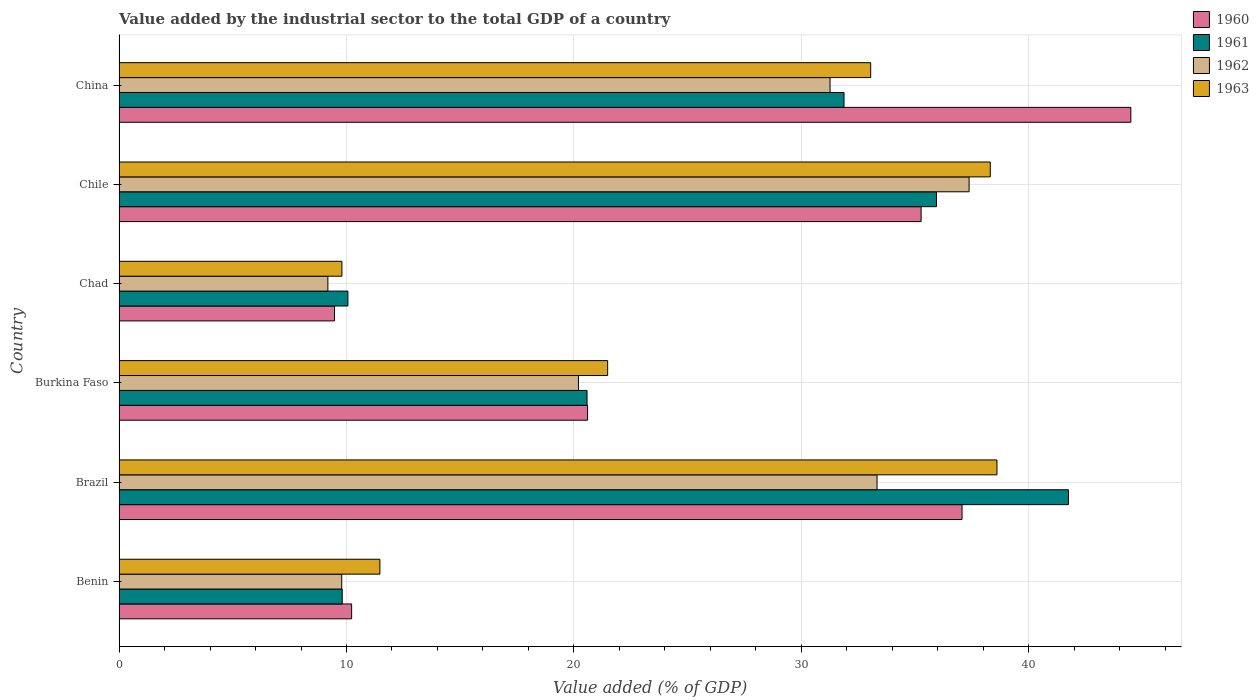How many different coloured bars are there?
Keep it short and to the point. 4. Are the number of bars per tick equal to the number of legend labels?
Keep it short and to the point. Yes. How many bars are there on the 5th tick from the top?
Give a very brief answer. 4. How many bars are there on the 5th tick from the bottom?
Offer a terse response. 4. What is the label of the 6th group of bars from the top?
Give a very brief answer. Benin. In how many cases, is the number of bars for a given country not equal to the number of legend labels?
Your answer should be compact. 0. What is the value added by the industrial sector to the total GDP in 1963 in Chad?
Make the answer very short. 9.8. Across all countries, what is the maximum value added by the industrial sector to the total GDP in 1961?
Provide a short and direct response. 41.75. Across all countries, what is the minimum value added by the industrial sector to the total GDP in 1963?
Offer a very short reply. 9.8. In which country was the value added by the industrial sector to the total GDP in 1960 maximum?
Offer a terse response. China. In which country was the value added by the industrial sector to the total GDP in 1962 minimum?
Provide a short and direct response. Chad. What is the total value added by the industrial sector to the total GDP in 1960 in the graph?
Keep it short and to the point. 157.12. What is the difference between the value added by the industrial sector to the total GDP in 1960 in Brazil and that in Chile?
Keep it short and to the point. 1.8. What is the difference between the value added by the industrial sector to the total GDP in 1963 in Benin and the value added by the industrial sector to the total GDP in 1960 in China?
Your answer should be very brief. -33.02. What is the average value added by the industrial sector to the total GDP in 1962 per country?
Ensure brevity in your answer.  23.52. What is the difference between the value added by the industrial sector to the total GDP in 1960 and value added by the industrial sector to the total GDP in 1963 in Benin?
Your answer should be compact. -1.24. What is the ratio of the value added by the industrial sector to the total GDP in 1962 in Benin to that in Chile?
Offer a terse response. 0.26. What is the difference between the highest and the second highest value added by the industrial sector to the total GDP in 1963?
Your response must be concise. 0.29. What is the difference between the highest and the lowest value added by the industrial sector to the total GDP in 1962?
Provide a short and direct response. 28.19. In how many countries, is the value added by the industrial sector to the total GDP in 1960 greater than the average value added by the industrial sector to the total GDP in 1960 taken over all countries?
Your answer should be compact. 3. Is the sum of the value added by the industrial sector to the total GDP in 1963 in Brazil and Burkina Faso greater than the maximum value added by the industrial sector to the total GDP in 1961 across all countries?
Give a very brief answer. Yes. What does the 2nd bar from the top in Burkina Faso represents?
Provide a succinct answer. 1962. Is it the case that in every country, the sum of the value added by the industrial sector to the total GDP in 1961 and value added by the industrial sector to the total GDP in 1962 is greater than the value added by the industrial sector to the total GDP in 1963?
Your answer should be compact. Yes. Are all the bars in the graph horizontal?
Your response must be concise. Yes. What is the difference between two consecutive major ticks on the X-axis?
Keep it short and to the point. 10. How many legend labels are there?
Ensure brevity in your answer.  4. What is the title of the graph?
Provide a short and direct response. Value added by the industrial sector to the total GDP of a country. What is the label or title of the X-axis?
Ensure brevity in your answer.  Value added (% of GDP). What is the Value added (% of GDP) of 1960 in Benin?
Your answer should be compact. 10.23. What is the Value added (% of GDP) in 1961 in Benin?
Your answer should be very brief. 9.81. What is the Value added (% of GDP) of 1962 in Benin?
Give a very brief answer. 9.79. What is the Value added (% of GDP) in 1963 in Benin?
Offer a terse response. 11.47. What is the Value added (% of GDP) of 1960 in Brazil?
Your answer should be very brief. 37.07. What is the Value added (% of GDP) of 1961 in Brazil?
Offer a very short reply. 41.75. What is the Value added (% of GDP) of 1962 in Brazil?
Ensure brevity in your answer.  33.33. What is the Value added (% of GDP) in 1963 in Brazil?
Offer a very short reply. 38.6. What is the Value added (% of GDP) in 1960 in Burkina Faso?
Offer a very short reply. 20.6. What is the Value added (% of GDP) of 1961 in Burkina Faso?
Offer a terse response. 20.58. What is the Value added (% of GDP) of 1962 in Burkina Faso?
Keep it short and to the point. 20.2. What is the Value added (% of GDP) in 1963 in Burkina Faso?
Keep it short and to the point. 21.48. What is the Value added (% of GDP) of 1960 in Chad?
Offer a very short reply. 9.47. What is the Value added (% of GDP) of 1961 in Chad?
Provide a short and direct response. 10.06. What is the Value added (% of GDP) of 1962 in Chad?
Give a very brief answer. 9.18. What is the Value added (% of GDP) of 1963 in Chad?
Your response must be concise. 9.8. What is the Value added (% of GDP) of 1960 in Chile?
Provide a succinct answer. 35.27. What is the Value added (% of GDP) in 1961 in Chile?
Provide a succinct answer. 35.94. What is the Value added (% of GDP) in 1962 in Chile?
Your answer should be very brief. 37.38. What is the Value added (% of GDP) of 1963 in Chile?
Offer a terse response. 38.31. What is the Value added (% of GDP) in 1960 in China?
Make the answer very short. 44.49. What is the Value added (% of GDP) of 1961 in China?
Your answer should be compact. 31.88. What is the Value added (% of GDP) in 1962 in China?
Your response must be concise. 31.26. What is the Value added (% of GDP) of 1963 in China?
Offer a very short reply. 33.05. Across all countries, what is the maximum Value added (% of GDP) in 1960?
Your answer should be compact. 44.49. Across all countries, what is the maximum Value added (% of GDP) in 1961?
Ensure brevity in your answer.  41.75. Across all countries, what is the maximum Value added (% of GDP) in 1962?
Your response must be concise. 37.38. Across all countries, what is the maximum Value added (% of GDP) of 1963?
Offer a very short reply. 38.6. Across all countries, what is the minimum Value added (% of GDP) in 1960?
Your answer should be compact. 9.47. Across all countries, what is the minimum Value added (% of GDP) of 1961?
Offer a very short reply. 9.81. Across all countries, what is the minimum Value added (% of GDP) in 1962?
Your answer should be very brief. 9.18. Across all countries, what is the minimum Value added (% of GDP) of 1963?
Give a very brief answer. 9.8. What is the total Value added (% of GDP) in 1960 in the graph?
Make the answer very short. 157.12. What is the total Value added (% of GDP) in 1961 in the graph?
Your response must be concise. 150.02. What is the total Value added (% of GDP) of 1962 in the graph?
Make the answer very short. 141.14. What is the total Value added (% of GDP) in 1963 in the graph?
Ensure brevity in your answer.  152.71. What is the difference between the Value added (% of GDP) of 1960 in Benin and that in Brazil?
Make the answer very short. -26.84. What is the difference between the Value added (% of GDP) of 1961 in Benin and that in Brazil?
Keep it short and to the point. -31.93. What is the difference between the Value added (% of GDP) in 1962 in Benin and that in Brazil?
Your answer should be compact. -23.54. What is the difference between the Value added (% of GDP) of 1963 in Benin and that in Brazil?
Provide a succinct answer. -27.13. What is the difference between the Value added (% of GDP) of 1960 in Benin and that in Burkina Faso?
Make the answer very short. -10.37. What is the difference between the Value added (% of GDP) of 1961 in Benin and that in Burkina Faso?
Make the answer very short. -10.76. What is the difference between the Value added (% of GDP) in 1962 in Benin and that in Burkina Faso?
Make the answer very short. -10.41. What is the difference between the Value added (% of GDP) of 1963 in Benin and that in Burkina Faso?
Ensure brevity in your answer.  -10.01. What is the difference between the Value added (% of GDP) of 1960 in Benin and that in Chad?
Offer a very short reply. 0.75. What is the difference between the Value added (% of GDP) of 1961 in Benin and that in Chad?
Your response must be concise. -0.25. What is the difference between the Value added (% of GDP) of 1962 in Benin and that in Chad?
Keep it short and to the point. 0.61. What is the difference between the Value added (% of GDP) of 1963 in Benin and that in Chad?
Your answer should be very brief. 1.67. What is the difference between the Value added (% of GDP) of 1960 in Benin and that in Chile?
Your answer should be compact. -25.04. What is the difference between the Value added (% of GDP) in 1961 in Benin and that in Chile?
Your response must be concise. -26.13. What is the difference between the Value added (% of GDP) in 1962 in Benin and that in Chile?
Make the answer very short. -27.59. What is the difference between the Value added (% of GDP) of 1963 in Benin and that in Chile?
Your response must be concise. -26.84. What is the difference between the Value added (% of GDP) of 1960 in Benin and that in China?
Your answer should be very brief. -34.26. What is the difference between the Value added (% of GDP) of 1961 in Benin and that in China?
Your answer should be compact. -22.06. What is the difference between the Value added (% of GDP) of 1962 in Benin and that in China?
Your answer should be very brief. -21.47. What is the difference between the Value added (% of GDP) of 1963 in Benin and that in China?
Offer a terse response. -21.58. What is the difference between the Value added (% of GDP) of 1960 in Brazil and that in Burkina Faso?
Make the answer very short. 16.47. What is the difference between the Value added (% of GDP) of 1961 in Brazil and that in Burkina Faso?
Offer a very short reply. 21.17. What is the difference between the Value added (% of GDP) of 1962 in Brazil and that in Burkina Faso?
Give a very brief answer. 13.13. What is the difference between the Value added (% of GDP) of 1963 in Brazil and that in Burkina Faso?
Your answer should be compact. 17.12. What is the difference between the Value added (% of GDP) of 1960 in Brazil and that in Chad?
Provide a short and direct response. 27.59. What is the difference between the Value added (% of GDP) in 1961 in Brazil and that in Chad?
Offer a terse response. 31.68. What is the difference between the Value added (% of GDP) of 1962 in Brazil and that in Chad?
Offer a very short reply. 24.15. What is the difference between the Value added (% of GDP) in 1963 in Brazil and that in Chad?
Your answer should be very brief. 28.8. What is the difference between the Value added (% of GDP) of 1960 in Brazil and that in Chile?
Ensure brevity in your answer.  1.8. What is the difference between the Value added (% of GDP) in 1961 in Brazil and that in Chile?
Make the answer very short. 5.8. What is the difference between the Value added (% of GDP) in 1962 in Brazil and that in Chile?
Offer a terse response. -4.05. What is the difference between the Value added (% of GDP) in 1963 in Brazil and that in Chile?
Keep it short and to the point. 0.29. What is the difference between the Value added (% of GDP) in 1960 in Brazil and that in China?
Give a very brief answer. -7.42. What is the difference between the Value added (% of GDP) of 1961 in Brazil and that in China?
Offer a terse response. 9.87. What is the difference between the Value added (% of GDP) in 1962 in Brazil and that in China?
Give a very brief answer. 2.07. What is the difference between the Value added (% of GDP) of 1963 in Brazil and that in China?
Your answer should be compact. 5.55. What is the difference between the Value added (% of GDP) in 1960 in Burkina Faso and that in Chad?
Provide a short and direct response. 11.13. What is the difference between the Value added (% of GDP) in 1961 in Burkina Faso and that in Chad?
Your answer should be compact. 10.52. What is the difference between the Value added (% of GDP) of 1962 in Burkina Faso and that in Chad?
Give a very brief answer. 11.02. What is the difference between the Value added (% of GDP) of 1963 in Burkina Faso and that in Chad?
Give a very brief answer. 11.68. What is the difference between the Value added (% of GDP) of 1960 in Burkina Faso and that in Chile?
Keep it short and to the point. -14.67. What is the difference between the Value added (% of GDP) in 1961 in Burkina Faso and that in Chile?
Keep it short and to the point. -15.37. What is the difference between the Value added (% of GDP) in 1962 in Burkina Faso and that in Chile?
Offer a terse response. -17.18. What is the difference between the Value added (% of GDP) in 1963 in Burkina Faso and that in Chile?
Your answer should be compact. -16.82. What is the difference between the Value added (% of GDP) in 1960 in Burkina Faso and that in China?
Ensure brevity in your answer.  -23.89. What is the difference between the Value added (% of GDP) of 1961 in Burkina Faso and that in China?
Ensure brevity in your answer.  -11.3. What is the difference between the Value added (% of GDP) of 1962 in Burkina Faso and that in China?
Your answer should be compact. -11.06. What is the difference between the Value added (% of GDP) of 1963 in Burkina Faso and that in China?
Make the answer very short. -11.57. What is the difference between the Value added (% of GDP) of 1960 in Chad and that in Chile?
Offer a very short reply. -25.79. What is the difference between the Value added (% of GDP) in 1961 in Chad and that in Chile?
Give a very brief answer. -25.88. What is the difference between the Value added (% of GDP) of 1962 in Chad and that in Chile?
Keep it short and to the point. -28.19. What is the difference between the Value added (% of GDP) in 1963 in Chad and that in Chile?
Keep it short and to the point. -28.51. What is the difference between the Value added (% of GDP) of 1960 in Chad and that in China?
Ensure brevity in your answer.  -35.01. What is the difference between the Value added (% of GDP) of 1961 in Chad and that in China?
Offer a terse response. -21.81. What is the difference between the Value added (% of GDP) in 1962 in Chad and that in China?
Give a very brief answer. -22.08. What is the difference between the Value added (% of GDP) in 1963 in Chad and that in China?
Your response must be concise. -23.25. What is the difference between the Value added (% of GDP) in 1960 in Chile and that in China?
Provide a short and direct response. -9.22. What is the difference between the Value added (% of GDP) of 1961 in Chile and that in China?
Offer a terse response. 4.07. What is the difference between the Value added (% of GDP) of 1962 in Chile and that in China?
Ensure brevity in your answer.  6.11. What is the difference between the Value added (% of GDP) in 1963 in Chile and that in China?
Offer a terse response. 5.26. What is the difference between the Value added (% of GDP) in 1960 in Benin and the Value added (% of GDP) in 1961 in Brazil?
Keep it short and to the point. -31.52. What is the difference between the Value added (% of GDP) of 1960 in Benin and the Value added (% of GDP) of 1962 in Brazil?
Provide a succinct answer. -23.1. What is the difference between the Value added (% of GDP) of 1960 in Benin and the Value added (% of GDP) of 1963 in Brazil?
Make the answer very short. -28.37. What is the difference between the Value added (% of GDP) of 1961 in Benin and the Value added (% of GDP) of 1962 in Brazil?
Give a very brief answer. -23.52. What is the difference between the Value added (% of GDP) in 1961 in Benin and the Value added (% of GDP) in 1963 in Brazil?
Your response must be concise. -28.79. What is the difference between the Value added (% of GDP) of 1962 in Benin and the Value added (% of GDP) of 1963 in Brazil?
Give a very brief answer. -28.81. What is the difference between the Value added (% of GDP) in 1960 in Benin and the Value added (% of GDP) in 1961 in Burkina Faso?
Provide a short and direct response. -10.35. What is the difference between the Value added (% of GDP) of 1960 in Benin and the Value added (% of GDP) of 1962 in Burkina Faso?
Ensure brevity in your answer.  -9.97. What is the difference between the Value added (% of GDP) in 1960 in Benin and the Value added (% of GDP) in 1963 in Burkina Faso?
Provide a short and direct response. -11.26. What is the difference between the Value added (% of GDP) of 1961 in Benin and the Value added (% of GDP) of 1962 in Burkina Faso?
Provide a short and direct response. -10.39. What is the difference between the Value added (% of GDP) of 1961 in Benin and the Value added (% of GDP) of 1963 in Burkina Faso?
Give a very brief answer. -11.67. What is the difference between the Value added (% of GDP) of 1962 in Benin and the Value added (% of GDP) of 1963 in Burkina Faso?
Ensure brevity in your answer.  -11.69. What is the difference between the Value added (% of GDP) of 1960 in Benin and the Value added (% of GDP) of 1961 in Chad?
Provide a succinct answer. 0.16. What is the difference between the Value added (% of GDP) of 1960 in Benin and the Value added (% of GDP) of 1962 in Chad?
Your response must be concise. 1.05. What is the difference between the Value added (% of GDP) of 1960 in Benin and the Value added (% of GDP) of 1963 in Chad?
Provide a succinct answer. 0.43. What is the difference between the Value added (% of GDP) of 1961 in Benin and the Value added (% of GDP) of 1962 in Chad?
Keep it short and to the point. 0.63. What is the difference between the Value added (% of GDP) of 1961 in Benin and the Value added (% of GDP) of 1963 in Chad?
Provide a short and direct response. 0.01. What is the difference between the Value added (% of GDP) in 1962 in Benin and the Value added (% of GDP) in 1963 in Chad?
Provide a succinct answer. -0.01. What is the difference between the Value added (% of GDP) in 1960 in Benin and the Value added (% of GDP) in 1961 in Chile?
Offer a very short reply. -25.72. What is the difference between the Value added (% of GDP) in 1960 in Benin and the Value added (% of GDP) in 1962 in Chile?
Offer a terse response. -27.15. What is the difference between the Value added (% of GDP) of 1960 in Benin and the Value added (% of GDP) of 1963 in Chile?
Make the answer very short. -28.08. What is the difference between the Value added (% of GDP) of 1961 in Benin and the Value added (% of GDP) of 1962 in Chile?
Give a very brief answer. -27.56. What is the difference between the Value added (% of GDP) in 1961 in Benin and the Value added (% of GDP) in 1963 in Chile?
Provide a succinct answer. -28.49. What is the difference between the Value added (% of GDP) in 1962 in Benin and the Value added (% of GDP) in 1963 in Chile?
Provide a succinct answer. -28.52. What is the difference between the Value added (% of GDP) of 1960 in Benin and the Value added (% of GDP) of 1961 in China?
Offer a very short reply. -21.65. What is the difference between the Value added (% of GDP) in 1960 in Benin and the Value added (% of GDP) in 1962 in China?
Provide a succinct answer. -21.04. What is the difference between the Value added (% of GDP) in 1960 in Benin and the Value added (% of GDP) in 1963 in China?
Make the answer very short. -22.82. What is the difference between the Value added (% of GDP) of 1961 in Benin and the Value added (% of GDP) of 1962 in China?
Provide a short and direct response. -21.45. What is the difference between the Value added (% of GDP) in 1961 in Benin and the Value added (% of GDP) in 1963 in China?
Provide a short and direct response. -23.24. What is the difference between the Value added (% of GDP) of 1962 in Benin and the Value added (% of GDP) of 1963 in China?
Provide a short and direct response. -23.26. What is the difference between the Value added (% of GDP) in 1960 in Brazil and the Value added (% of GDP) in 1961 in Burkina Faso?
Make the answer very short. 16.49. What is the difference between the Value added (% of GDP) in 1960 in Brazil and the Value added (% of GDP) in 1962 in Burkina Faso?
Give a very brief answer. 16.87. What is the difference between the Value added (% of GDP) in 1960 in Brazil and the Value added (% of GDP) in 1963 in Burkina Faso?
Offer a terse response. 15.58. What is the difference between the Value added (% of GDP) in 1961 in Brazil and the Value added (% of GDP) in 1962 in Burkina Faso?
Offer a very short reply. 21.54. What is the difference between the Value added (% of GDP) of 1961 in Brazil and the Value added (% of GDP) of 1963 in Burkina Faso?
Keep it short and to the point. 20.26. What is the difference between the Value added (% of GDP) of 1962 in Brazil and the Value added (% of GDP) of 1963 in Burkina Faso?
Give a very brief answer. 11.85. What is the difference between the Value added (% of GDP) of 1960 in Brazil and the Value added (% of GDP) of 1961 in Chad?
Offer a very short reply. 27. What is the difference between the Value added (% of GDP) of 1960 in Brazil and the Value added (% of GDP) of 1962 in Chad?
Your answer should be compact. 27.88. What is the difference between the Value added (% of GDP) of 1960 in Brazil and the Value added (% of GDP) of 1963 in Chad?
Your response must be concise. 27.27. What is the difference between the Value added (% of GDP) of 1961 in Brazil and the Value added (% of GDP) of 1962 in Chad?
Your response must be concise. 32.56. What is the difference between the Value added (% of GDP) of 1961 in Brazil and the Value added (% of GDP) of 1963 in Chad?
Offer a terse response. 31.95. What is the difference between the Value added (% of GDP) in 1962 in Brazil and the Value added (% of GDP) in 1963 in Chad?
Make the answer very short. 23.53. What is the difference between the Value added (% of GDP) in 1960 in Brazil and the Value added (% of GDP) in 1961 in Chile?
Ensure brevity in your answer.  1.12. What is the difference between the Value added (% of GDP) of 1960 in Brazil and the Value added (% of GDP) of 1962 in Chile?
Your answer should be very brief. -0.31. What is the difference between the Value added (% of GDP) of 1960 in Brazil and the Value added (% of GDP) of 1963 in Chile?
Your answer should be very brief. -1.24. What is the difference between the Value added (% of GDP) in 1961 in Brazil and the Value added (% of GDP) in 1962 in Chile?
Offer a very short reply. 4.37. What is the difference between the Value added (% of GDP) in 1961 in Brazil and the Value added (% of GDP) in 1963 in Chile?
Provide a succinct answer. 3.44. What is the difference between the Value added (% of GDP) of 1962 in Brazil and the Value added (% of GDP) of 1963 in Chile?
Your answer should be compact. -4.98. What is the difference between the Value added (% of GDP) of 1960 in Brazil and the Value added (% of GDP) of 1961 in China?
Your answer should be very brief. 5.19. What is the difference between the Value added (% of GDP) in 1960 in Brazil and the Value added (% of GDP) in 1962 in China?
Give a very brief answer. 5.8. What is the difference between the Value added (% of GDP) of 1960 in Brazil and the Value added (% of GDP) of 1963 in China?
Your answer should be very brief. 4.02. What is the difference between the Value added (% of GDP) of 1961 in Brazil and the Value added (% of GDP) of 1962 in China?
Offer a very short reply. 10.48. What is the difference between the Value added (% of GDP) in 1961 in Brazil and the Value added (% of GDP) in 1963 in China?
Provide a succinct answer. 8.7. What is the difference between the Value added (% of GDP) in 1962 in Brazil and the Value added (% of GDP) in 1963 in China?
Offer a very short reply. 0.28. What is the difference between the Value added (% of GDP) of 1960 in Burkina Faso and the Value added (% of GDP) of 1961 in Chad?
Provide a succinct answer. 10.54. What is the difference between the Value added (% of GDP) of 1960 in Burkina Faso and the Value added (% of GDP) of 1962 in Chad?
Give a very brief answer. 11.42. What is the difference between the Value added (% of GDP) of 1960 in Burkina Faso and the Value added (% of GDP) of 1963 in Chad?
Ensure brevity in your answer.  10.8. What is the difference between the Value added (% of GDP) of 1961 in Burkina Faso and the Value added (% of GDP) of 1962 in Chad?
Your answer should be very brief. 11.4. What is the difference between the Value added (% of GDP) in 1961 in Burkina Faso and the Value added (% of GDP) in 1963 in Chad?
Keep it short and to the point. 10.78. What is the difference between the Value added (% of GDP) of 1962 in Burkina Faso and the Value added (% of GDP) of 1963 in Chad?
Provide a succinct answer. 10.4. What is the difference between the Value added (% of GDP) in 1960 in Burkina Faso and the Value added (% of GDP) in 1961 in Chile?
Ensure brevity in your answer.  -15.34. What is the difference between the Value added (% of GDP) in 1960 in Burkina Faso and the Value added (% of GDP) in 1962 in Chile?
Offer a terse response. -16.78. What is the difference between the Value added (% of GDP) in 1960 in Burkina Faso and the Value added (% of GDP) in 1963 in Chile?
Offer a terse response. -17.71. What is the difference between the Value added (% of GDP) of 1961 in Burkina Faso and the Value added (% of GDP) of 1962 in Chile?
Provide a succinct answer. -16.8. What is the difference between the Value added (% of GDP) of 1961 in Burkina Faso and the Value added (% of GDP) of 1963 in Chile?
Keep it short and to the point. -17.73. What is the difference between the Value added (% of GDP) in 1962 in Burkina Faso and the Value added (% of GDP) in 1963 in Chile?
Make the answer very short. -18.11. What is the difference between the Value added (% of GDP) in 1960 in Burkina Faso and the Value added (% of GDP) in 1961 in China?
Your answer should be compact. -11.28. What is the difference between the Value added (% of GDP) of 1960 in Burkina Faso and the Value added (% of GDP) of 1962 in China?
Make the answer very short. -10.66. What is the difference between the Value added (% of GDP) in 1960 in Burkina Faso and the Value added (% of GDP) in 1963 in China?
Provide a succinct answer. -12.45. What is the difference between the Value added (% of GDP) of 1961 in Burkina Faso and the Value added (% of GDP) of 1962 in China?
Provide a short and direct response. -10.68. What is the difference between the Value added (% of GDP) in 1961 in Burkina Faso and the Value added (% of GDP) in 1963 in China?
Your answer should be compact. -12.47. What is the difference between the Value added (% of GDP) of 1962 in Burkina Faso and the Value added (% of GDP) of 1963 in China?
Keep it short and to the point. -12.85. What is the difference between the Value added (% of GDP) in 1960 in Chad and the Value added (% of GDP) in 1961 in Chile?
Provide a short and direct response. -26.47. What is the difference between the Value added (% of GDP) in 1960 in Chad and the Value added (% of GDP) in 1962 in Chile?
Offer a very short reply. -27.9. What is the difference between the Value added (% of GDP) of 1960 in Chad and the Value added (% of GDP) of 1963 in Chile?
Your response must be concise. -28.83. What is the difference between the Value added (% of GDP) in 1961 in Chad and the Value added (% of GDP) in 1962 in Chile?
Your answer should be compact. -27.31. What is the difference between the Value added (% of GDP) in 1961 in Chad and the Value added (% of GDP) in 1963 in Chile?
Give a very brief answer. -28.25. What is the difference between the Value added (% of GDP) of 1962 in Chad and the Value added (% of GDP) of 1963 in Chile?
Offer a very short reply. -29.13. What is the difference between the Value added (% of GDP) of 1960 in Chad and the Value added (% of GDP) of 1961 in China?
Offer a very short reply. -22.4. What is the difference between the Value added (% of GDP) in 1960 in Chad and the Value added (% of GDP) in 1962 in China?
Provide a succinct answer. -21.79. What is the difference between the Value added (% of GDP) of 1960 in Chad and the Value added (% of GDP) of 1963 in China?
Keep it short and to the point. -23.58. What is the difference between the Value added (% of GDP) in 1961 in Chad and the Value added (% of GDP) in 1962 in China?
Ensure brevity in your answer.  -21.2. What is the difference between the Value added (% of GDP) in 1961 in Chad and the Value added (% of GDP) in 1963 in China?
Make the answer very short. -22.99. What is the difference between the Value added (% of GDP) of 1962 in Chad and the Value added (% of GDP) of 1963 in China?
Give a very brief answer. -23.87. What is the difference between the Value added (% of GDP) in 1960 in Chile and the Value added (% of GDP) in 1961 in China?
Ensure brevity in your answer.  3.39. What is the difference between the Value added (% of GDP) of 1960 in Chile and the Value added (% of GDP) of 1962 in China?
Provide a short and direct response. 4. What is the difference between the Value added (% of GDP) in 1960 in Chile and the Value added (% of GDP) in 1963 in China?
Keep it short and to the point. 2.22. What is the difference between the Value added (% of GDP) in 1961 in Chile and the Value added (% of GDP) in 1962 in China?
Give a very brief answer. 4.68. What is the difference between the Value added (% of GDP) of 1961 in Chile and the Value added (% of GDP) of 1963 in China?
Offer a terse response. 2.89. What is the difference between the Value added (% of GDP) of 1962 in Chile and the Value added (% of GDP) of 1963 in China?
Your answer should be very brief. 4.33. What is the average Value added (% of GDP) in 1960 per country?
Keep it short and to the point. 26.19. What is the average Value added (% of GDP) of 1961 per country?
Your answer should be compact. 25. What is the average Value added (% of GDP) of 1962 per country?
Your response must be concise. 23.52. What is the average Value added (% of GDP) in 1963 per country?
Ensure brevity in your answer.  25.45. What is the difference between the Value added (% of GDP) of 1960 and Value added (% of GDP) of 1961 in Benin?
Offer a terse response. 0.41. What is the difference between the Value added (% of GDP) in 1960 and Value added (% of GDP) in 1962 in Benin?
Make the answer very short. 0.44. What is the difference between the Value added (% of GDP) of 1960 and Value added (% of GDP) of 1963 in Benin?
Ensure brevity in your answer.  -1.24. What is the difference between the Value added (% of GDP) in 1961 and Value added (% of GDP) in 1962 in Benin?
Offer a terse response. 0.02. What is the difference between the Value added (% of GDP) of 1961 and Value added (% of GDP) of 1963 in Benin?
Your response must be concise. -1.66. What is the difference between the Value added (% of GDP) of 1962 and Value added (% of GDP) of 1963 in Benin?
Your answer should be compact. -1.68. What is the difference between the Value added (% of GDP) of 1960 and Value added (% of GDP) of 1961 in Brazil?
Your answer should be compact. -4.68. What is the difference between the Value added (% of GDP) in 1960 and Value added (% of GDP) in 1962 in Brazil?
Your answer should be compact. 3.74. What is the difference between the Value added (% of GDP) of 1960 and Value added (% of GDP) of 1963 in Brazil?
Ensure brevity in your answer.  -1.53. What is the difference between the Value added (% of GDP) of 1961 and Value added (% of GDP) of 1962 in Brazil?
Make the answer very short. 8.42. What is the difference between the Value added (% of GDP) in 1961 and Value added (% of GDP) in 1963 in Brazil?
Provide a short and direct response. 3.14. What is the difference between the Value added (% of GDP) in 1962 and Value added (% of GDP) in 1963 in Brazil?
Offer a terse response. -5.27. What is the difference between the Value added (% of GDP) of 1960 and Value added (% of GDP) of 1961 in Burkina Faso?
Your answer should be very brief. 0.02. What is the difference between the Value added (% of GDP) of 1960 and Value added (% of GDP) of 1962 in Burkina Faso?
Give a very brief answer. 0.4. What is the difference between the Value added (% of GDP) in 1960 and Value added (% of GDP) in 1963 in Burkina Faso?
Keep it short and to the point. -0.88. What is the difference between the Value added (% of GDP) of 1961 and Value added (% of GDP) of 1962 in Burkina Faso?
Offer a terse response. 0.38. What is the difference between the Value added (% of GDP) in 1961 and Value added (% of GDP) in 1963 in Burkina Faso?
Provide a succinct answer. -0.91. What is the difference between the Value added (% of GDP) of 1962 and Value added (% of GDP) of 1963 in Burkina Faso?
Provide a succinct answer. -1.28. What is the difference between the Value added (% of GDP) of 1960 and Value added (% of GDP) of 1961 in Chad?
Offer a very short reply. -0.59. What is the difference between the Value added (% of GDP) in 1960 and Value added (% of GDP) in 1962 in Chad?
Offer a terse response. 0.29. What is the difference between the Value added (% of GDP) of 1960 and Value added (% of GDP) of 1963 in Chad?
Provide a succinct answer. -0.32. What is the difference between the Value added (% of GDP) of 1961 and Value added (% of GDP) of 1962 in Chad?
Provide a succinct answer. 0.88. What is the difference between the Value added (% of GDP) in 1961 and Value added (% of GDP) in 1963 in Chad?
Provide a succinct answer. 0.26. What is the difference between the Value added (% of GDP) in 1962 and Value added (% of GDP) in 1963 in Chad?
Keep it short and to the point. -0.62. What is the difference between the Value added (% of GDP) in 1960 and Value added (% of GDP) in 1961 in Chile?
Give a very brief answer. -0.68. What is the difference between the Value added (% of GDP) of 1960 and Value added (% of GDP) of 1962 in Chile?
Your answer should be very brief. -2.11. What is the difference between the Value added (% of GDP) of 1960 and Value added (% of GDP) of 1963 in Chile?
Your answer should be compact. -3.04. What is the difference between the Value added (% of GDP) of 1961 and Value added (% of GDP) of 1962 in Chile?
Your answer should be very brief. -1.43. What is the difference between the Value added (% of GDP) in 1961 and Value added (% of GDP) in 1963 in Chile?
Give a very brief answer. -2.36. What is the difference between the Value added (% of GDP) of 1962 and Value added (% of GDP) of 1963 in Chile?
Offer a very short reply. -0.93. What is the difference between the Value added (% of GDP) in 1960 and Value added (% of GDP) in 1961 in China?
Your answer should be very brief. 12.61. What is the difference between the Value added (% of GDP) in 1960 and Value added (% of GDP) in 1962 in China?
Provide a short and direct response. 13.23. What is the difference between the Value added (% of GDP) in 1960 and Value added (% of GDP) in 1963 in China?
Provide a succinct answer. 11.44. What is the difference between the Value added (% of GDP) of 1961 and Value added (% of GDP) of 1962 in China?
Make the answer very short. 0.61. What is the difference between the Value added (% of GDP) of 1961 and Value added (% of GDP) of 1963 in China?
Give a very brief answer. -1.17. What is the difference between the Value added (% of GDP) of 1962 and Value added (% of GDP) of 1963 in China?
Your answer should be compact. -1.79. What is the ratio of the Value added (% of GDP) in 1960 in Benin to that in Brazil?
Offer a terse response. 0.28. What is the ratio of the Value added (% of GDP) of 1961 in Benin to that in Brazil?
Keep it short and to the point. 0.24. What is the ratio of the Value added (% of GDP) of 1962 in Benin to that in Brazil?
Your response must be concise. 0.29. What is the ratio of the Value added (% of GDP) in 1963 in Benin to that in Brazil?
Your answer should be compact. 0.3. What is the ratio of the Value added (% of GDP) in 1960 in Benin to that in Burkina Faso?
Give a very brief answer. 0.5. What is the ratio of the Value added (% of GDP) of 1961 in Benin to that in Burkina Faso?
Your answer should be very brief. 0.48. What is the ratio of the Value added (% of GDP) of 1962 in Benin to that in Burkina Faso?
Ensure brevity in your answer.  0.48. What is the ratio of the Value added (% of GDP) of 1963 in Benin to that in Burkina Faso?
Offer a terse response. 0.53. What is the ratio of the Value added (% of GDP) of 1960 in Benin to that in Chad?
Provide a succinct answer. 1.08. What is the ratio of the Value added (% of GDP) of 1961 in Benin to that in Chad?
Make the answer very short. 0.98. What is the ratio of the Value added (% of GDP) of 1962 in Benin to that in Chad?
Give a very brief answer. 1.07. What is the ratio of the Value added (% of GDP) in 1963 in Benin to that in Chad?
Your answer should be compact. 1.17. What is the ratio of the Value added (% of GDP) of 1960 in Benin to that in Chile?
Offer a terse response. 0.29. What is the ratio of the Value added (% of GDP) in 1961 in Benin to that in Chile?
Ensure brevity in your answer.  0.27. What is the ratio of the Value added (% of GDP) in 1962 in Benin to that in Chile?
Keep it short and to the point. 0.26. What is the ratio of the Value added (% of GDP) of 1963 in Benin to that in Chile?
Keep it short and to the point. 0.3. What is the ratio of the Value added (% of GDP) in 1960 in Benin to that in China?
Keep it short and to the point. 0.23. What is the ratio of the Value added (% of GDP) of 1961 in Benin to that in China?
Give a very brief answer. 0.31. What is the ratio of the Value added (% of GDP) in 1962 in Benin to that in China?
Provide a short and direct response. 0.31. What is the ratio of the Value added (% of GDP) in 1963 in Benin to that in China?
Make the answer very short. 0.35. What is the ratio of the Value added (% of GDP) in 1960 in Brazil to that in Burkina Faso?
Offer a terse response. 1.8. What is the ratio of the Value added (% of GDP) in 1961 in Brazil to that in Burkina Faso?
Offer a terse response. 2.03. What is the ratio of the Value added (% of GDP) of 1962 in Brazil to that in Burkina Faso?
Provide a short and direct response. 1.65. What is the ratio of the Value added (% of GDP) of 1963 in Brazil to that in Burkina Faso?
Keep it short and to the point. 1.8. What is the ratio of the Value added (% of GDP) of 1960 in Brazil to that in Chad?
Your answer should be compact. 3.91. What is the ratio of the Value added (% of GDP) of 1961 in Brazil to that in Chad?
Make the answer very short. 4.15. What is the ratio of the Value added (% of GDP) in 1962 in Brazil to that in Chad?
Provide a succinct answer. 3.63. What is the ratio of the Value added (% of GDP) of 1963 in Brazil to that in Chad?
Give a very brief answer. 3.94. What is the ratio of the Value added (% of GDP) in 1960 in Brazil to that in Chile?
Provide a succinct answer. 1.05. What is the ratio of the Value added (% of GDP) of 1961 in Brazil to that in Chile?
Keep it short and to the point. 1.16. What is the ratio of the Value added (% of GDP) of 1962 in Brazil to that in Chile?
Keep it short and to the point. 0.89. What is the ratio of the Value added (% of GDP) of 1963 in Brazil to that in Chile?
Give a very brief answer. 1.01. What is the ratio of the Value added (% of GDP) of 1960 in Brazil to that in China?
Give a very brief answer. 0.83. What is the ratio of the Value added (% of GDP) of 1961 in Brazil to that in China?
Ensure brevity in your answer.  1.31. What is the ratio of the Value added (% of GDP) of 1962 in Brazil to that in China?
Your answer should be compact. 1.07. What is the ratio of the Value added (% of GDP) in 1963 in Brazil to that in China?
Ensure brevity in your answer.  1.17. What is the ratio of the Value added (% of GDP) of 1960 in Burkina Faso to that in Chad?
Your answer should be very brief. 2.17. What is the ratio of the Value added (% of GDP) in 1961 in Burkina Faso to that in Chad?
Give a very brief answer. 2.04. What is the ratio of the Value added (% of GDP) in 1962 in Burkina Faso to that in Chad?
Offer a very short reply. 2.2. What is the ratio of the Value added (% of GDP) of 1963 in Burkina Faso to that in Chad?
Keep it short and to the point. 2.19. What is the ratio of the Value added (% of GDP) in 1960 in Burkina Faso to that in Chile?
Your answer should be very brief. 0.58. What is the ratio of the Value added (% of GDP) of 1961 in Burkina Faso to that in Chile?
Give a very brief answer. 0.57. What is the ratio of the Value added (% of GDP) in 1962 in Burkina Faso to that in Chile?
Your answer should be very brief. 0.54. What is the ratio of the Value added (% of GDP) in 1963 in Burkina Faso to that in Chile?
Make the answer very short. 0.56. What is the ratio of the Value added (% of GDP) of 1960 in Burkina Faso to that in China?
Give a very brief answer. 0.46. What is the ratio of the Value added (% of GDP) of 1961 in Burkina Faso to that in China?
Make the answer very short. 0.65. What is the ratio of the Value added (% of GDP) in 1962 in Burkina Faso to that in China?
Your answer should be compact. 0.65. What is the ratio of the Value added (% of GDP) of 1963 in Burkina Faso to that in China?
Give a very brief answer. 0.65. What is the ratio of the Value added (% of GDP) in 1960 in Chad to that in Chile?
Provide a succinct answer. 0.27. What is the ratio of the Value added (% of GDP) in 1961 in Chad to that in Chile?
Your response must be concise. 0.28. What is the ratio of the Value added (% of GDP) of 1962 in Chad to that in Chile?
Your response must be concise. 0.25. What is the ratio of the Value added (% of GDP) of 1963 in Chad to that in Chile?
Your answer should be compact. 0.26. What is the ratio of the Value added (% of GDP) of 1960 in Chad to that in China?
Provide a succinct answer. 0.21. What is the ratio of the Value added (% of GDP) of 1961 in Chad to that in China?
Your answer should be very brief. 0.32. What is the ratio of the Value added (% of GDP) in 1962 in Chad to that in China?
Your answer should be compact. 0.29. What is the ratio of the Value added (% of GDP) of 1963 in Chad to that in China?
Your answer should be compact. 0.3. What is the ratio of the Value added (% of GDP) of 1960 in Chile to that in China?
Ensure brevity in your answer.  0.79. What is the ratio of the Value added (% of GDP) in 1961 in Chile to that in China?
Ensure brevity in your answer.  1.13. What is the ratio of the Value added (% of GDP) in 1962 in Chile to that in China?
Your answer should be very brief. 1.2. What is the ratio of the Value added (% of GDP) of 1963 in Chile to that in China?
Ensure brevity in your answer.  1.16. What is the difference between the highest and the second highest Value added (% of GDP) in 1960?
Keep it short and to the point. 7.42. What is the difference between the highest and the second highest Value added (% of GDP) in 1961?
Your answer should be compact. 5.8. What is the difference between the highest and the second highest Value added (% of GDP) of 1962?
Your answer should be compact. 4.05. What is the difference between the highest and the second highest Value added (% of GDP) in 1963?
Ensure brevity in your answer.  0.29. What is the difference between the highest and the lowest Value added (% of GDP) in 1960?
Provide a short and direct response. 35.01. What is the difference between the highest and the lowest Value added (% of GDP) of 1961?
Your answer should be compact. 31.93. What is the difference between the highest and the lowest Value added (% of GDP) of 1962?
Your answer should be compact. 28.19. What is the difference between the highest and the lowest Value added (% of GDP) in 1963?
Offer a very short reply. 28.8. 